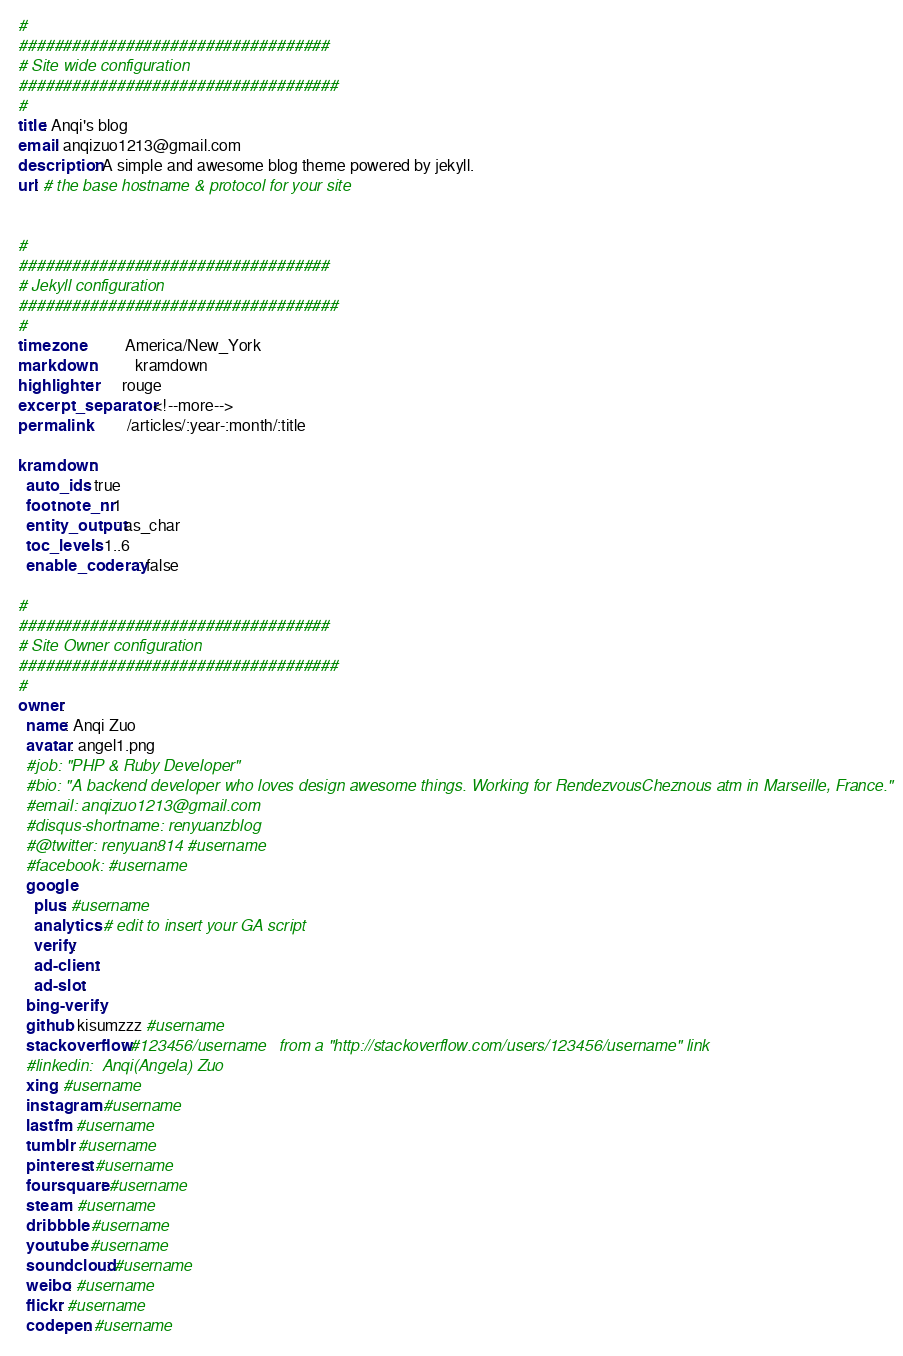<code> <loc_0><loc_0><loc_500><loc_500><_YAML_>#
###################################
# Site wide configuration
####################################
#
title: Anqi's blog
email: anqizuo1213@gmail.com
description: A simple and awesome blog theme powered by jekyll.
url: # the base hostname & protocol for your site


#
###################################
# Jekyll configuration
####################################
#
timezone:          America/New_York
markdown:          kramdown
highlighter:       rouge
excerpt_separator: <!--more-->
permalink:         /articles/:year-:month/:title

kramdown:
  auto_ids: true
  footnote_nr: 1
  entity_output: as_char
  toc_levels: 1..6
  enable_coderay: false

#
###################################
# Site Owner configuration
####################################
#
owner:
  name: Anqi Zuo
  avatar: angel1.png
  #job: "PHP & Ruby Developer"
  #bio: "A backend developer who loves design awesome things. Working for RendezvousCheznous atm in Marseille, France."
  #email: anqizuo1213@gmail.com
  #disqus-shortname: renyuanzblog
  #@twitter: renyuan814 #username
  #facebook: #username
  google:
    plus: #username
    analytics: # edit to insert your GA script
    verify:
    ad-client:
    ad-slot:
  bing-verify:
  github: kisumzzz #username
  stackoverflow: #123456/username   from a "http://stackoverflow.com/users/123456/username" link
  #linkedin:  Anqi(Angela) Zuo
  xing: #username
  instagram: #username
  lastfm: #username
  tumblr: #username
  pinterest: #username
  foursquare: #username
  steam: #username
  dribbble: #username
  youtube: #username
  soundcloud: #username
  weibo: #username
  flickr: #username
  codepen: #username
</code> 